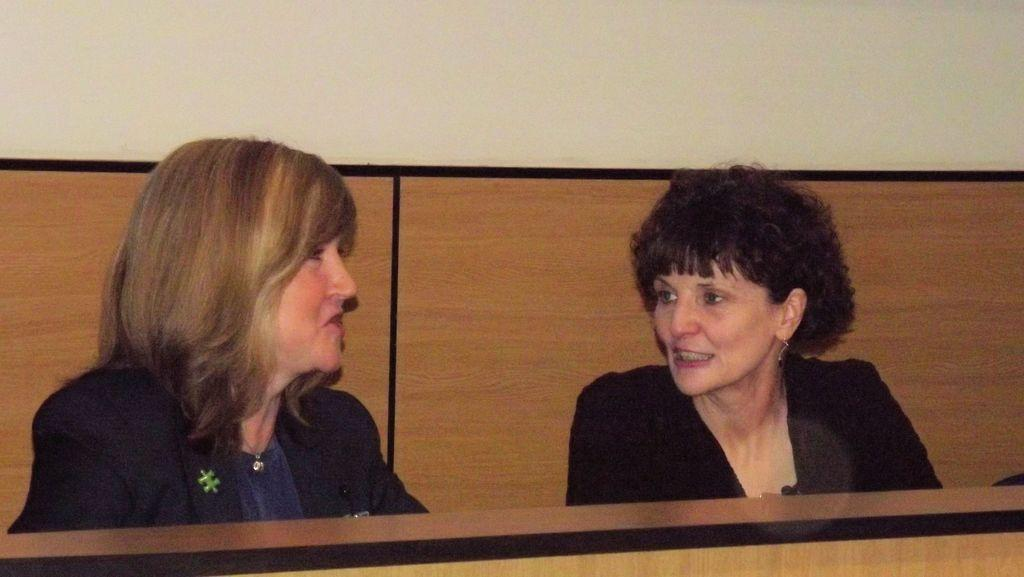How many people are in the image? There are two persons in the image. What are the two persons doing in the image? The two persons are sitting. What expression do the two persons have in the image? The two persons are smiling. What is the chance of the two persons breaking the world record for sitting and smiling in the image? There is no information about world records or chances in the image, so it cannot be determined. 